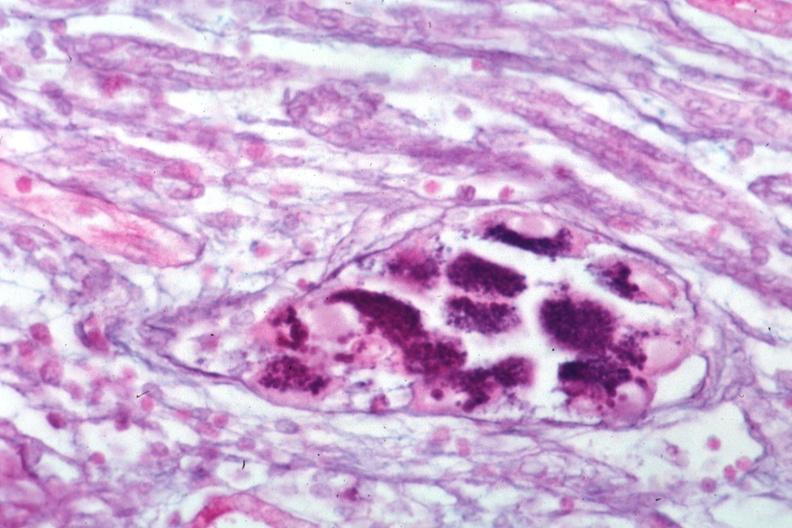s kidney present?
Answer the question using a single word or phrase. Yes 